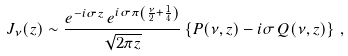<formula> <loc_0><loc_0><loc_500><loc_500>J _ { \nu } ( z ) \sim \frac { e ^ { - i \sigma z } \, e ^ { i \sigma \pi \left ( \frac { \nu } { 2 } + \frac { 1 } { 4 } \right ) } } { \sqrt { 2 \pi z } } \left \{ P ( \nu , z ) - i \sigma \, Q ( \nu , z ) \right \} \, ,</formula> 